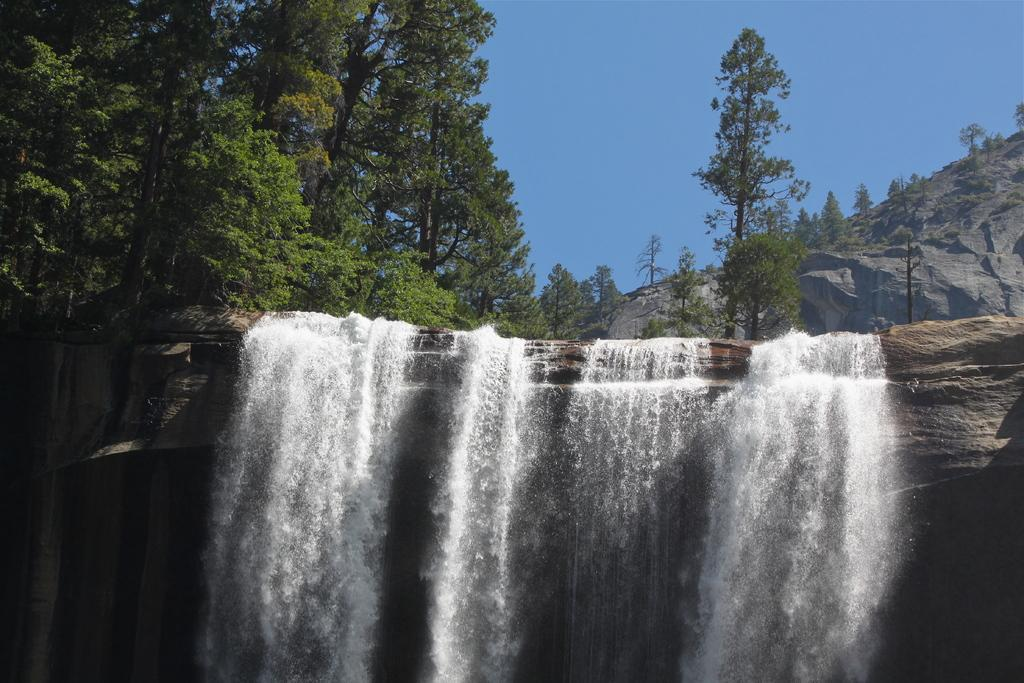What natural feature is the main subject of the image? There is a waterfall in the image. What type of vegetation can be seen in the background of the image? There are trees in the background of the image. What object is located on the right side of the image? There is a pole on the right side of the image. What other geographical feature is visible in the background of the image? There is a mountain in the background of the image. What part of the natural environment is visible in the background of the image? The sky is visible in the background of the image. What language is spoken by the cherries in the image? There are no cherries present in the image, and therefore no language can be attributed to them. 